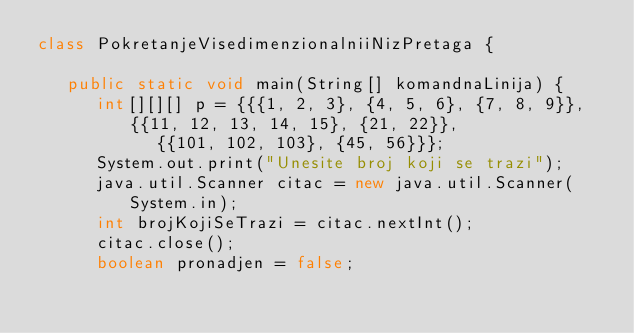Convert code to text. <code><loc_0><loc_0><loc_500><loc_500><_Java_>class PokretanjeVisedimenzionalniiNizPretaga {

   public static void main(String[] komandnaLinija) {
      int[][][] p = {{{1, 2, 3}, {4, 5, 6}, {7, 8, 9}}, {{11, 12, 13, 14, 15}, {21, 22}},
            {{101, 102, 103}, {45, 56}}};
      System.out.print("Unesite broj koji se trazi");
      java.util.Scanner citac = new java.util.Scanner(System.in);
      int brojKojiSeTrazi = citac.nextInt();
      citac.close();
      boolean pronadjen = false;</code> 